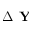Convert formula to latex. <formula><loc_0><loc_0><loc_500><loc_500>\Delta Y</formula> 